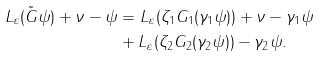<formula> <loc_0><loc_0><loc_500><loc_500>L _ { \varepsilon } ( \tilde { G } \psi ) + \nu - \psi & = L _ { \varepsilon } ( \zeta _ { 1 } G _ { 1 } ( \gamma _ { 1 } \psi ) ) + \nu - \gamma _ { 1 } \psi \\ & + L _ { \varepsilon } ( \zeta _ { 2 } G _ { 2 } ( \gamma _ { 2 } \psi ) ) - \gamma _ { 2 } \psi .</formula> 